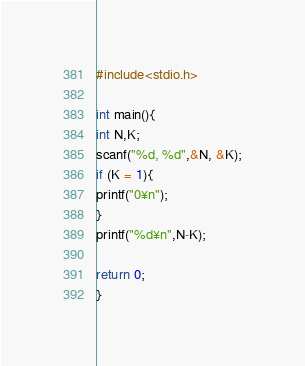Convert code to text. <code><loc_0><loc_0><loc_500><loc_500><_C_>#include<stdio.h>

int main(){
int N,K;
scanf("%d, %d",&N, &K);
if (K = 1){
printf("0¥n");
}
printf("%d¥n",N-K);

return 0;
}</code> 